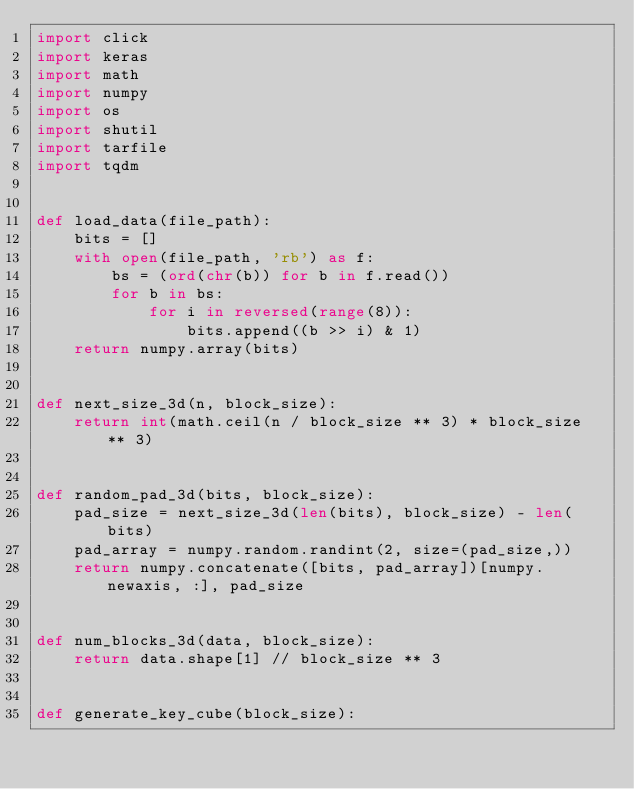Convert code to text. <code><loc_0><loc_0><loc_500><loc_500><_Python_>import click
import keras
import math
import numpy
import os
import shutil
import tarfile
import tqdm


def load_data(file_path):
    bits = []
    with open(file_path, 'rb') as f:
        bs = (ord(chr(b)) for b in f.read())
        for b in bs:
            for i in reversed(range(8)):
                bits.append((b >> i) & 1)
    return numpy.array(bits)


def next_size_3d(n, block_size):
    return int(math.ceil(n / block_size ** 3) * block_size ** 3)


def random_pad_3d(bits, block_size):
    pad_size = next_size_3d(len(bits), block_size) - len(bits)
    pad_array = numpy.random.randint(2, size=(pad_size,))
    return numpy.concatenate([bits, pad_array])[numpy.newaxis, :], pad_size


def num_blocks_3d(data, block_size):
    return data.shape[1] // block_size ** 3


def generate_key_cube(block_size):</code> 